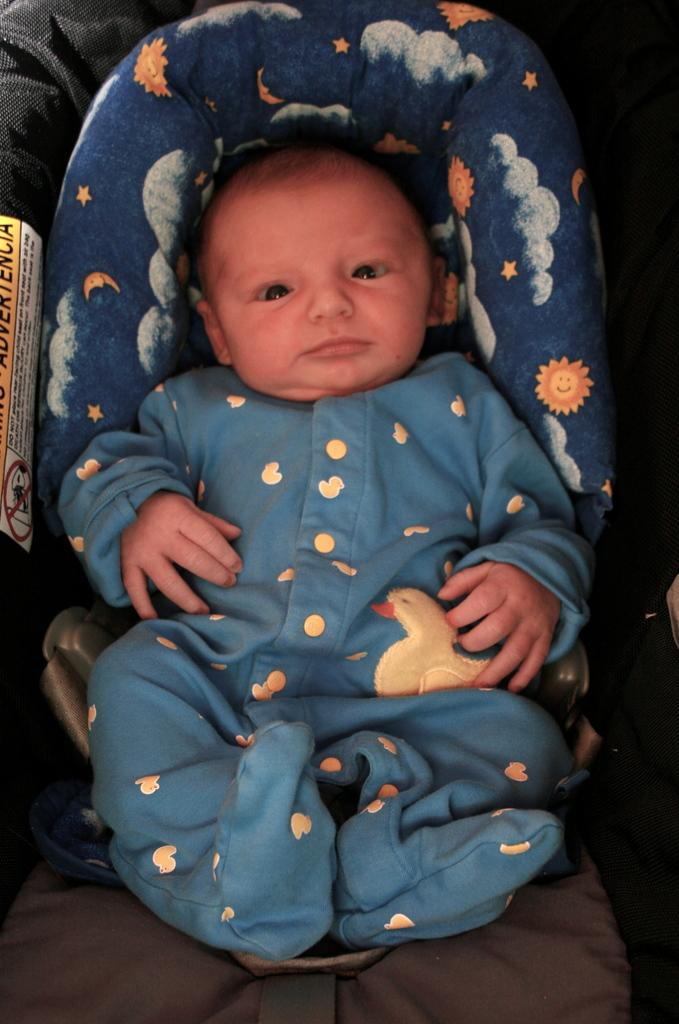What is the main subject of the image? There is a baby in the image. What is the baby wearing? The baby is wearing a green dress. What is the baby laying on? The baby is laying on a green object. What songs can be heard playing in the background of the image? There is no audio or background music present in the image, so it's not possible to determine what songs might be heard. 